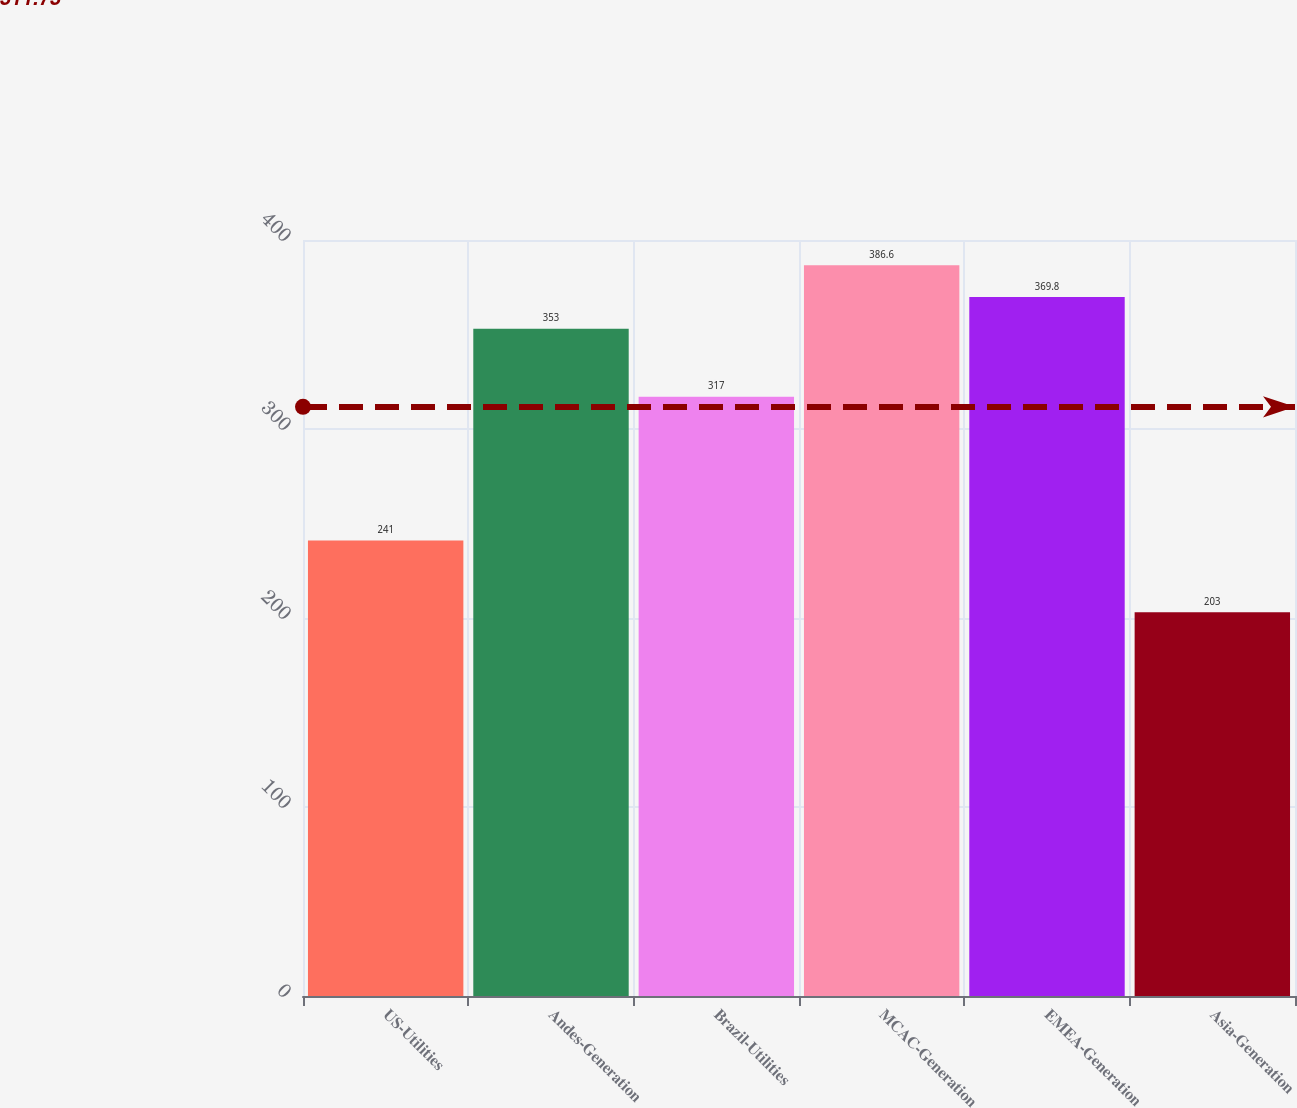Convert chart. <chart><loc_0><loc_0><loc_500><loc_500><bar_chart><fcel>US-Utilities<fcel>Andes-Generation<fcel>Brazil-Utilities<fcel>MCAC-Generation<fcel>EMEA-Generation<fcel>Asia-Generation<nl><fcel>241<fcel>353<fcel>317<fcel>386.6<fcel>369.8<fcel>203<nl></chart> 